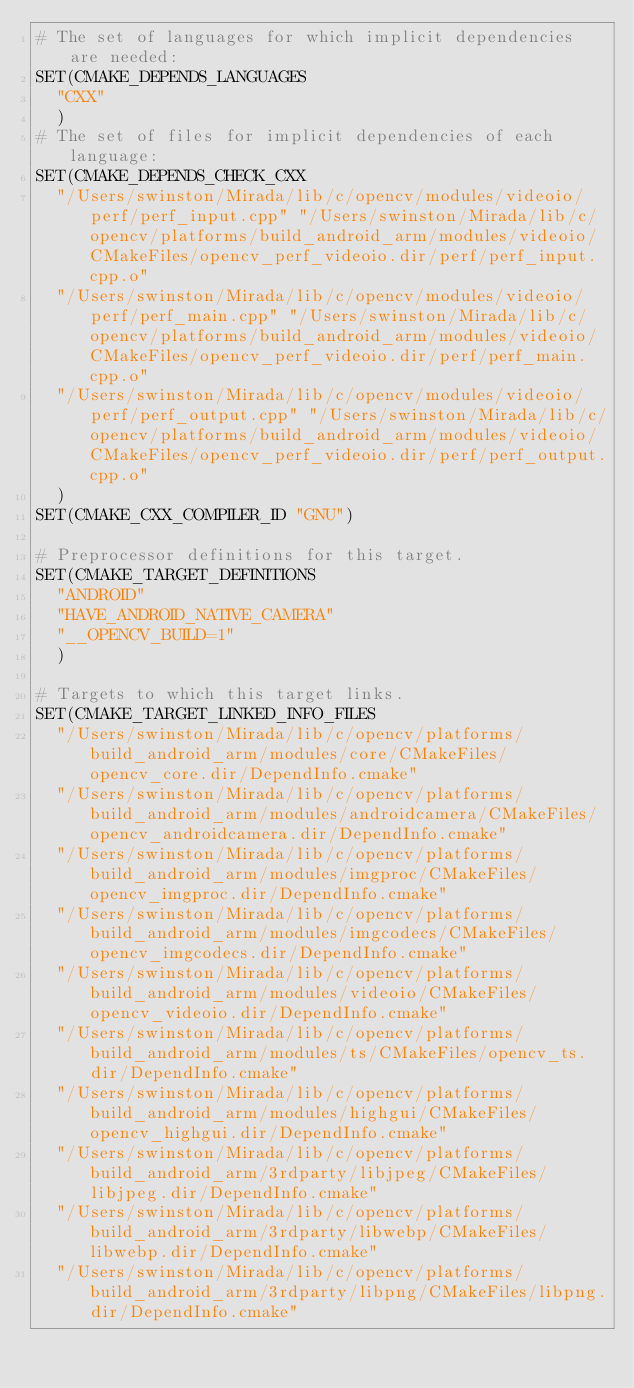<code> <loc_0><loc_0><loc_500><loc_500><_CMake_># The set of languages for which implicit dependencies are needed:
SET(CMAKE_DEPENDS_LANGUAGES
  "CXX"
  )
# The set of files for implicit dependencies of each language:
SET(CMAKE_DEPENDS_CHECK_CXX
  "/Users/swinston/Mirada/lib/c/opencv/modules/videoio/perf/perf_input.cpp" "/Users/swinston/Mirada/lib/c/opencv/platforms/build_android_arm/modules/videoio/CMakeFiles/opencv_perf_videoio.dir/perf/perf_input.cpp.o"
  "/Users/swinston/Mirada/lib/c/opencv/modules/videoio/perf/perf_main.cpp" "/Users/swinston/Mirada/lib/c/opencv/platforms/build_android_arm/modules/videoio/CMakeFiles/opencv_perf_videoio.dir/perf/perf_main.cpp.o"
  "/Users/swinston/Mirada/lib/c/opencv/modules/videoio/perf/perf_output.cpp" "/Users/swinston/Mirada/lib/c/opencv/platforms/build_android_arm/modules/videoio/CMakeFiles/opencv_perf_videoio.dir/perf/perf_output.cpp.o"
  )
SET(CMAKE_CXX_COMPILER_ID "GNU")

# Preprocessor definitions for this target.
SET(CMAKE_TARGET_DEFINITIONS
  "ANDROID"
  "HAVE_ANDROID_NATIVE_CAMERA"
  "__OPENCV_BUILD=1"
  )

# Targets to which this target links.
SET(CMAKE_TARGET_LINKED_INFO_FILES
  "/Users/swinston/Mirada/lib/c/opencv/platforms/build_android_arm/modules/core/CMakeFiles/opencv_core.dir/DependInfo.cmake"
  "/Users/swinston/Mirada/lib/c/opencv/platforms/build_android_arm/modules/androidcamera/CMakeFiles/opencv_androidcamera.dir/DependInfo.cmake"
  "/Users/swinston/Mirada/lib/c/opencv/platforms/build_android_arm/modules/imgproc/CMakeFiles/opencv_imgproc.dir/DependInfo.cmake"
  "/Users/swinston/Mirada/lib/c/opencv/platforms/build_android_arm/modules/imgcodecs/CMakeFiles/opencv_imgcodecs.dir/DependInfo.cmake"
  "/Users/swinston/Mirada/lib/c/opencv/platforms/build_android_arm/modules/videoio/CMakeFiles/opencv_videoio.dir/DependInfo.cmake"
  "/Users/swinston/Mirada/lib/c/opencv/platforms/build_android_arm/modules/ts/CMakeFiles/opencv_ts.dir/DependInfo.cmake"
  "/Users/swinston/Mirada/lib/c/opencv/platforms/build_android_arm/modules/highgui/CMakeFiles/opencv_highgui.dir/DependInfo.cmake"
  "/Users/swinston/Mirada/lib/c/opencv/platforms/build_android_arm/3rdparty/libjpeg/CMakeFiles/libjpeg.dir/DependInfo.cmake"
  "/Users/swinston/Mirada/lib/c/opencv/platforms/build_android_arm/3rdparty/libwebp/CMakeFiles/libwebp.dir/DependInfo.cmake"
  "/Users/swinston/Mirada/lib/c/opencv/platforms/build_android_arm/3rdparty/libpng/CMakeFiles/libpng.dir/DependInfo.cmake"</code> 